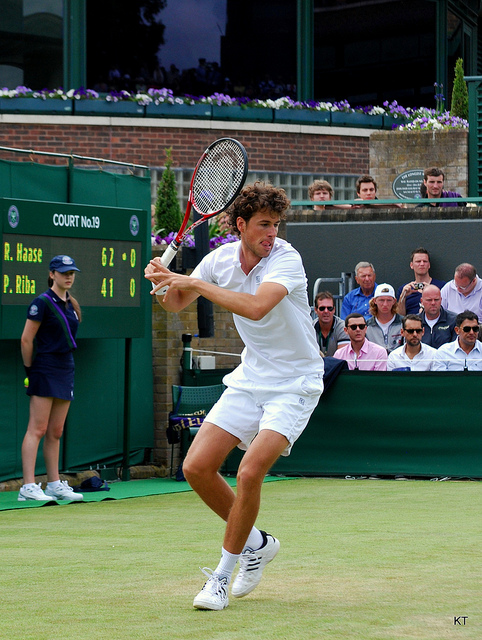<image>What brand of tennis racket does the man have? I am not sure about the brand of the tennis racket the man has. It could be 'spalding', 'champion', 'wilson', or 'phillips'. What brand of tennis racket does the man have? I don't know the brand of tennis racket the man has. It could be 'spalding', 'champion', 'wilson', or 'phillips'. 